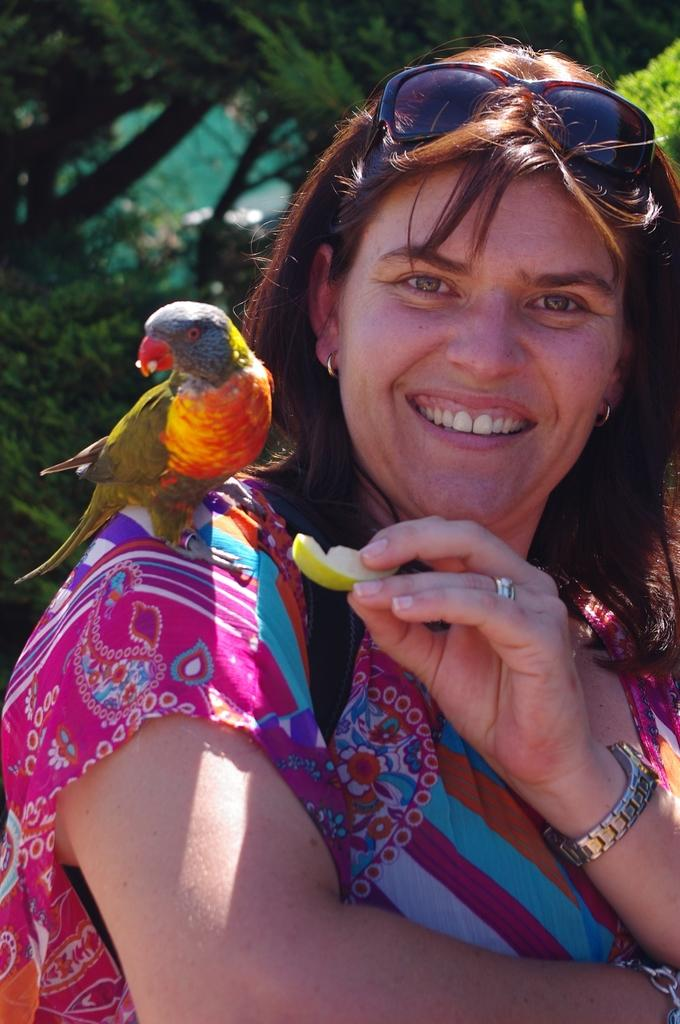Who is present in the image? There is a woman in the image. What is the woman holding in her hand? The woman is holding a fruit in her hand. Is there any other living creature in the image besides the woman? Yes, there is a bird on the woman's shoulder. What is the woman's facial expression? The woman is smiling. What can be seen in the background of the image? There are trees in the background of the image. What type of fang can be seen in the image? There is no fang present in the image. Is the woman wearing a suit in the image? The provided facts do not mention the woman wearing a suit, so we cannot determine that from the image. 